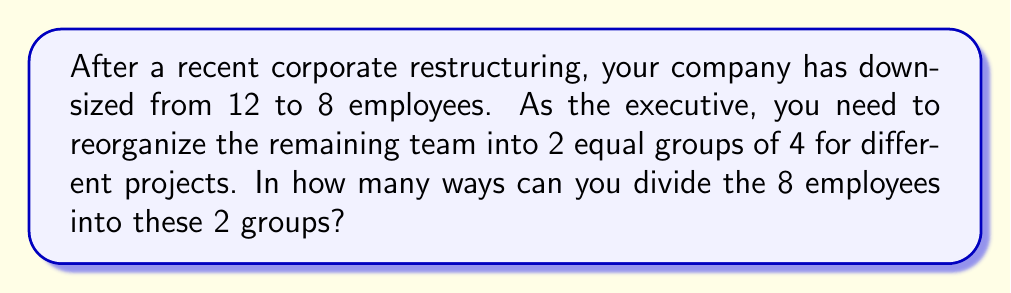Could you help me with this problem? Let's approach this step-by-step:

1) First, we need to understand that this is a combination problem. We're selecting 4 employees out of 8 for the first group, and the remaining 4 will automatically form the second group.

2) This can be represented as $\binom{8}{4}$, which is read as "8 choose 4".

3) The formula for this combination is:

   $$\binom{8}{4} = \frac{8!}{4!(8-4)!} = \frac{8!}{4!4!}$$

4) Let's expand this:
   
   $$\frac{8 \cdot 7 \cdot 6 \cdot 5 \cdot 4!}{(4 \cdot 3 \cdot 2 \cdot 1)(4 \cdot 3 \cdot 2 \cdot 1)}$$

5) The 4! cancels out in the numerator and denominator:

   $$\frac{8 \cdot 7 \cdot 6 \cdot 5}{4 \cdot 3 \cdot 2 \cdot 1} = \frac{1680}{24} = 70$$

6) However, this counts each division twice. For example, (A,B,C,D) and (E,F,G,H) is the same division as (E,F,G,H) and (A,B,C,D). We need to divide our result by 2 to account for this.

7) Therefore, the final number of ways to divide the team is:

   $$\frac{70}{2} = 35$$

This problem relates to your situation as an executive reorganizing a team after downsizing, which might be a task you're facing after your recent health challenges.
Answer: 35 ways 